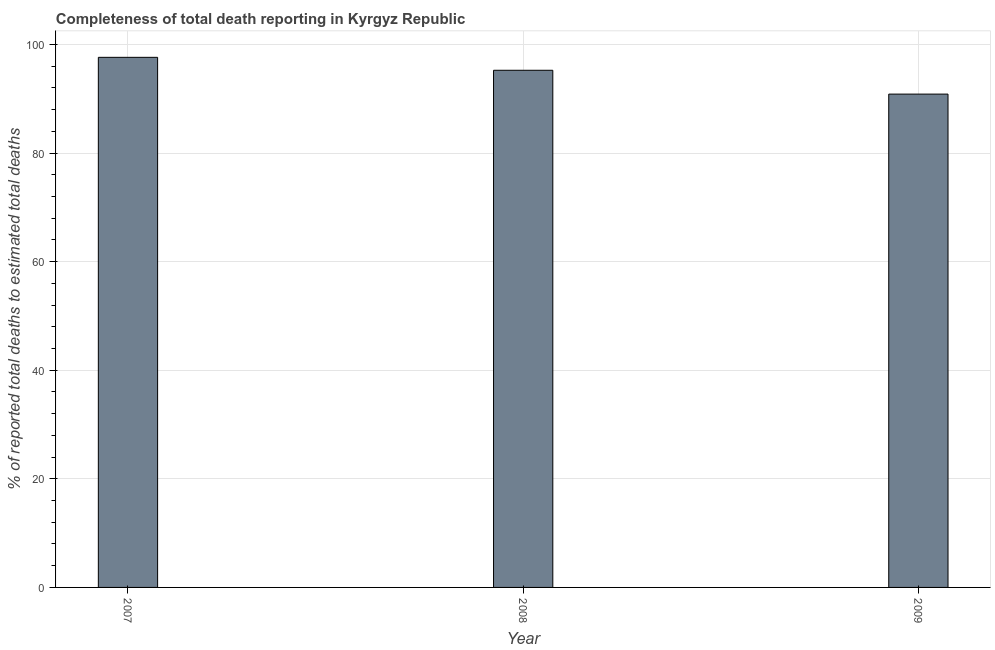Does the graph contain any zero values?
Keep it short and to the point. No. What is the title of the graph?
Ensure brevity in your answer.  Completeness of total death reporting in Kyrgyz Republic. What is the label or title of the Y-axis?
Give a very brief answer. % of reported total deaths to estimated total deaths. What is the completeness of total death reports in 2007?
Provide a succinct answer. 97.65. Across all years, what is the maximum completeness of total death reports?
Your answer should be compact. 97.65. Across all years, what is the minimum completeness of total death reports?
Your answer should be very brief. 90.87. In which year was the completeness of total death reports maximum?
Make the answer very short. 2007. In which year was the completeness of total death reports minimum?
Give a very brief answer. 2009. What is the sum of the completeness of total death reports?
Make the answer very short. 283.79. What is the difference between the completeness of total death reports in 2007 and 2008?
Your response must be concise. 2.38. What is the average completeness of total death reports per year?
Offer a very short reply. 94.59. What is the median completeness of total death reports?
Your answer should be very brief. 95.26. Do a majority of the years between 2009 and 2007 (inclusive) have completeness of total death reports greater than 56 %?
Provide a succinct answer. Yes. What is the ratio of the completeness of total death reports in 2007 to that in 2009?
Your response must be concise. 1.07. What is the difference between the highest and the second highest completeness of total death reports?
Keep it short and to the point. 2.38. What is the difference between the highest and the lowest completeness of total death reports?
Keep it short and to the point. 6.77. How many bars are there?
Make the answer very short. 3. Are all the bars in the graph horizontal?
Ensure brevity in your answer.  No. Are the values on the major ticks of Y-axis written in scientific E-notation?
Offer a very short reply. No. What is the % of reported total deaths to estimated total deaths of 2007?
Make the answer very short. 97.65. What is the % of reported total deaths to estimated total deaths of 2008?
Ensure brevity in your answer.  95.26. What is the % of reported total deaths to estimated total deaths in 2009?
Ensure brevity in your answer.  90.87. What is the difference between the % of reported total deaths to estimated total deaths in 2007 and 2008?
Ensure brevity in your answer.  2.38. What is the difference between the % of reported total deaths to estimated total deaths in 2007 and 2009?
Provide a short and direct response. 6.77. What is the difference between the % of reported total deaths to estimated total deaths in 2008 and 2009?
Give a very brief answer. 4.39. What is the ratio of the % of reported total deaths to estimated total deaths in 2007 to that in 2009?
Keep it short and to the point. 1.07. What is the ratio of the % of reported total deaths to estimated total deaths in 2008 to that in 2009?
Offer a very short reply. 1.05. 